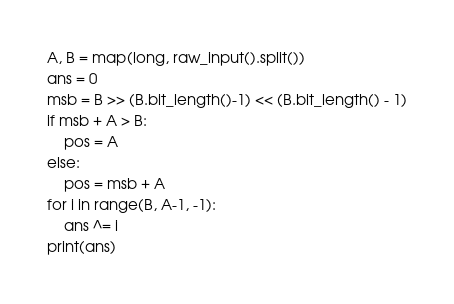<code> <loc_0><loc_0><loc_500><loc_500><_Python_>A, B = map(long, raw_input().split())
ans = 0
msb = B >> (B.bit_length()-1) << (B.bit_length() - 1)
if msb + A > B:
    pos = A
else:
    pos = msb + A
for i in range(B, A-1, -1):
    ans ^= i
print(ans)
</code> 